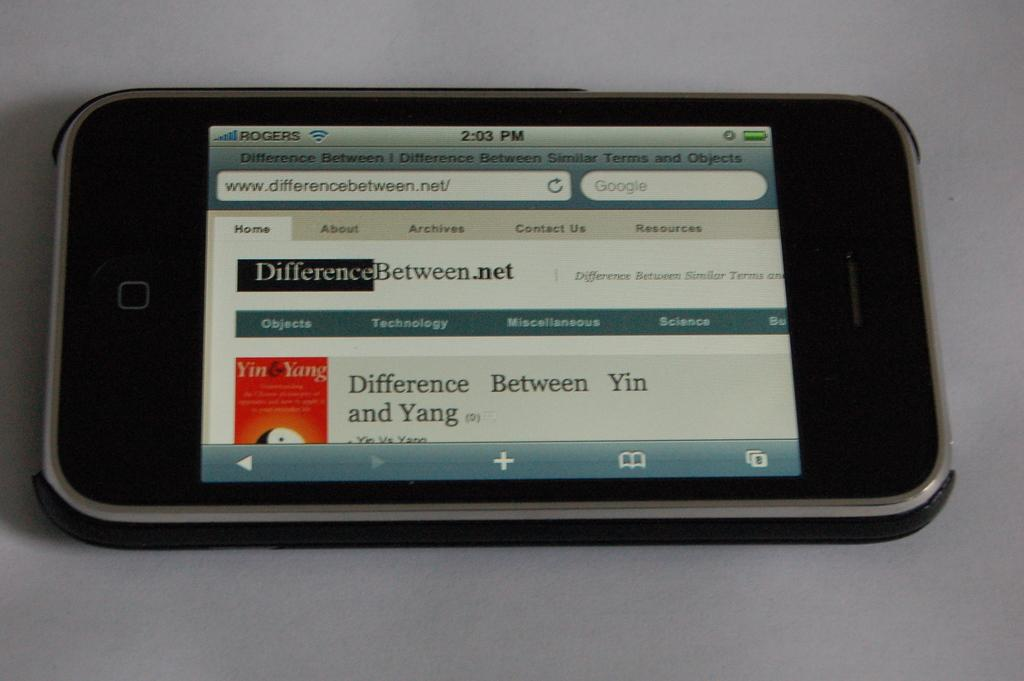<image>
Render a clear and concise summary of the photo. the screen of a cellphone open to a page reading Difference Between.net 